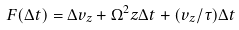<formula> <loc_0><loc_0><loc_500><loc_500>F ( \Delta t ) = \Delta v _ { z } + \Omega ^ { 2 } z \Delta t + ( v _ { z } / \tau ) \Delta t</formula> 